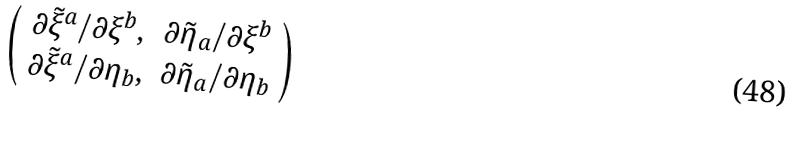<formula> <loc_0><loc_0><loc_500><loc_500>\left ( \begin{array} { c c } \partial \tilde { \xi } ^ { a } / \partial \xi ^ { b } , & \partial \tilde { \eta } _ { a } / \partial \xi ^ { b } \\ \partial \tilde { \xi } ^ { a } / \partial \eta _ { b } , & \partial \tilde { \eta } _ { a } / \partial \eta _ { b } \end{array} \right )</formula> 